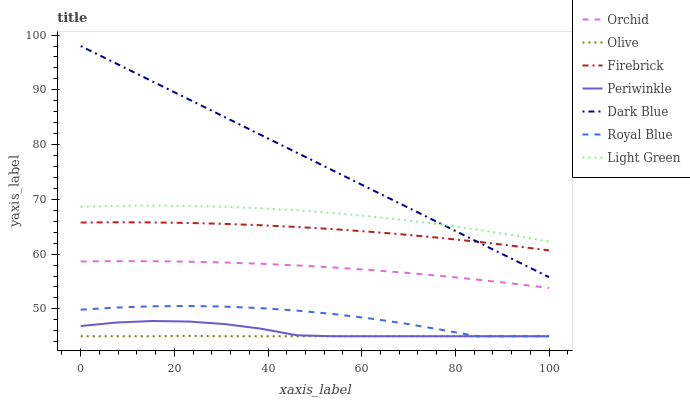Does Olive have the minimum area under the curve?
Answer yes or no. Yes. Does Dark Blue have the maximum area under the curve?
Answer yes or no. Yes. Does Firebrick have the minimum area under the curve?
Answer yes or no. No. Does Firebrick have the maximum area under the curve?
Answer yes or no. No. Is Dark Blue the smoothest?
Answer yes or no. Yes. Is Periwinkle the roughest?
Answer yes or no. Yes. Is Firebrick the smoothest?
Answer yes or no. No. Is Firebrick the roughest?
Answer yes or no. No. Does Royal Blue have the lowest value?
Answer yes or no. Yes. Does Firebrick have the lowest value?
Answer yes or no. No. Does Dark Blue have the highest value?
Answer yes or no. Yes. Does Firebrick have the highest value?
Answer yes or no. No. Is Orchid less than Light Green?
Answer yes or no. Yes. Is Light Green greater than Royal Blue?
Answer yes or no. Yes. Does Periwinkle intersect Royal Blue?
Answer yes or no. Yes. Is Periwinkle less than Royal Blue?
Answer yes or no. No. Is Periwinkle greater than Royal Blue?
Answer yes or no. No. Does Orchid intersect Light Green?
Answer yes or no. No. 